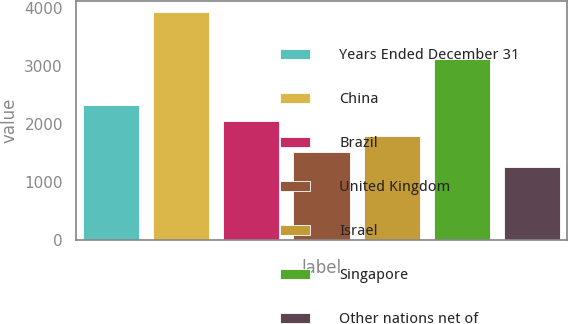<chart> <loc_0><loc_0><loc_500><loc_500><bar_chart><fcel>Years Ended December 31<fcel>China<fcel>Brazil<fcel>United Kingdom<fcel>Israel<fcel>Singapore<fcel>Other nations net of<nl><fcel>2327.6<fcel>3926<fcel>2061.2<fcel>1528.4<fcel>1794.8<fcel>3120<fcel>1262<nl></chart> 